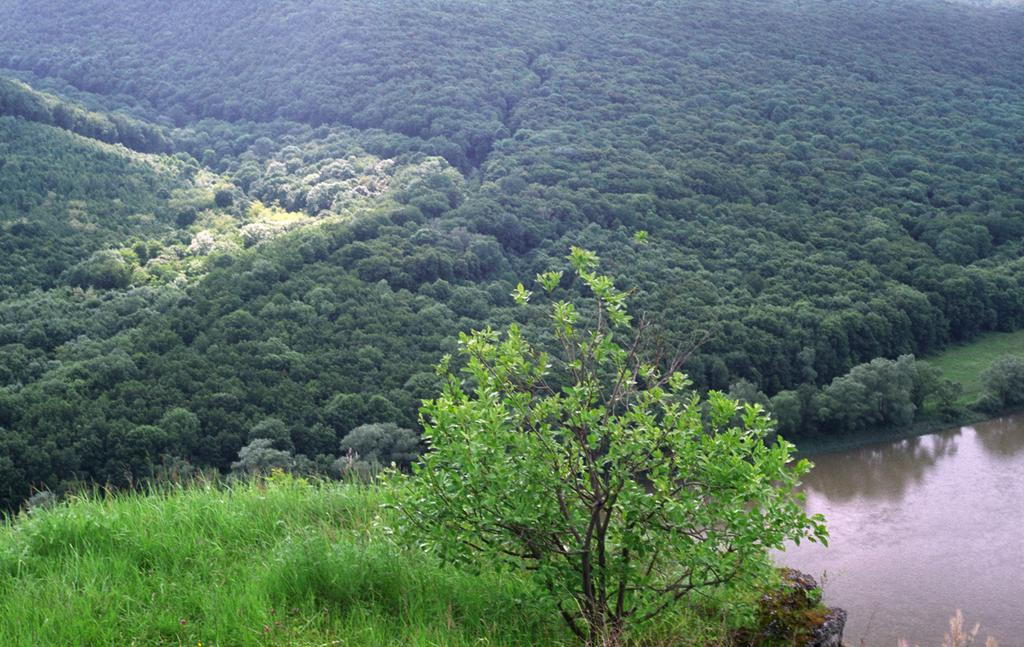What is the setting of the image? The image is an outside view. What can be seen in the bottom right of the image? There is a river in the bottom right of the image. What type of vegetation is visible at the bottom of the image? Grass is visible at the bottom of the image. What other plant life is present in the image? There is a plant in the image. What can be seen in the background of the image? There are many trees in the background of the image. What type of volleyball game is being played in the image? There is no volleyball game present in the image; it is an outside view with a river, grass, plant, and trees. How does the society depicted in the image contribute to the environment? There is no society depicted in the image; it is a natural scene with no human presence. 